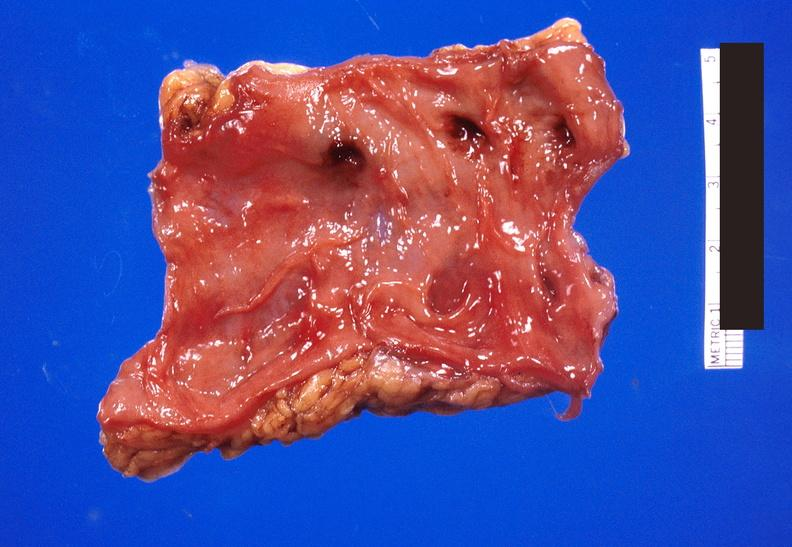where does this belong to?
Answer the question using a single word or phrase. Gastrointestinal system 